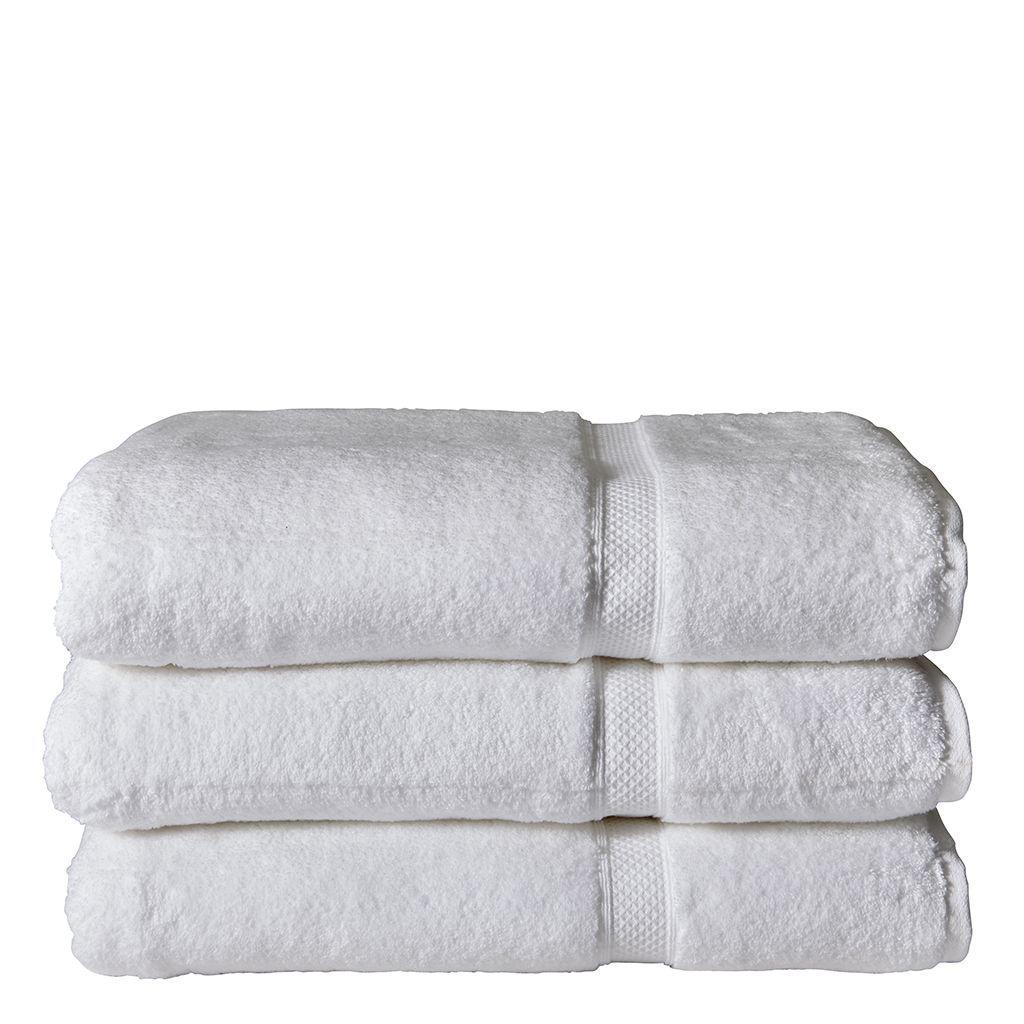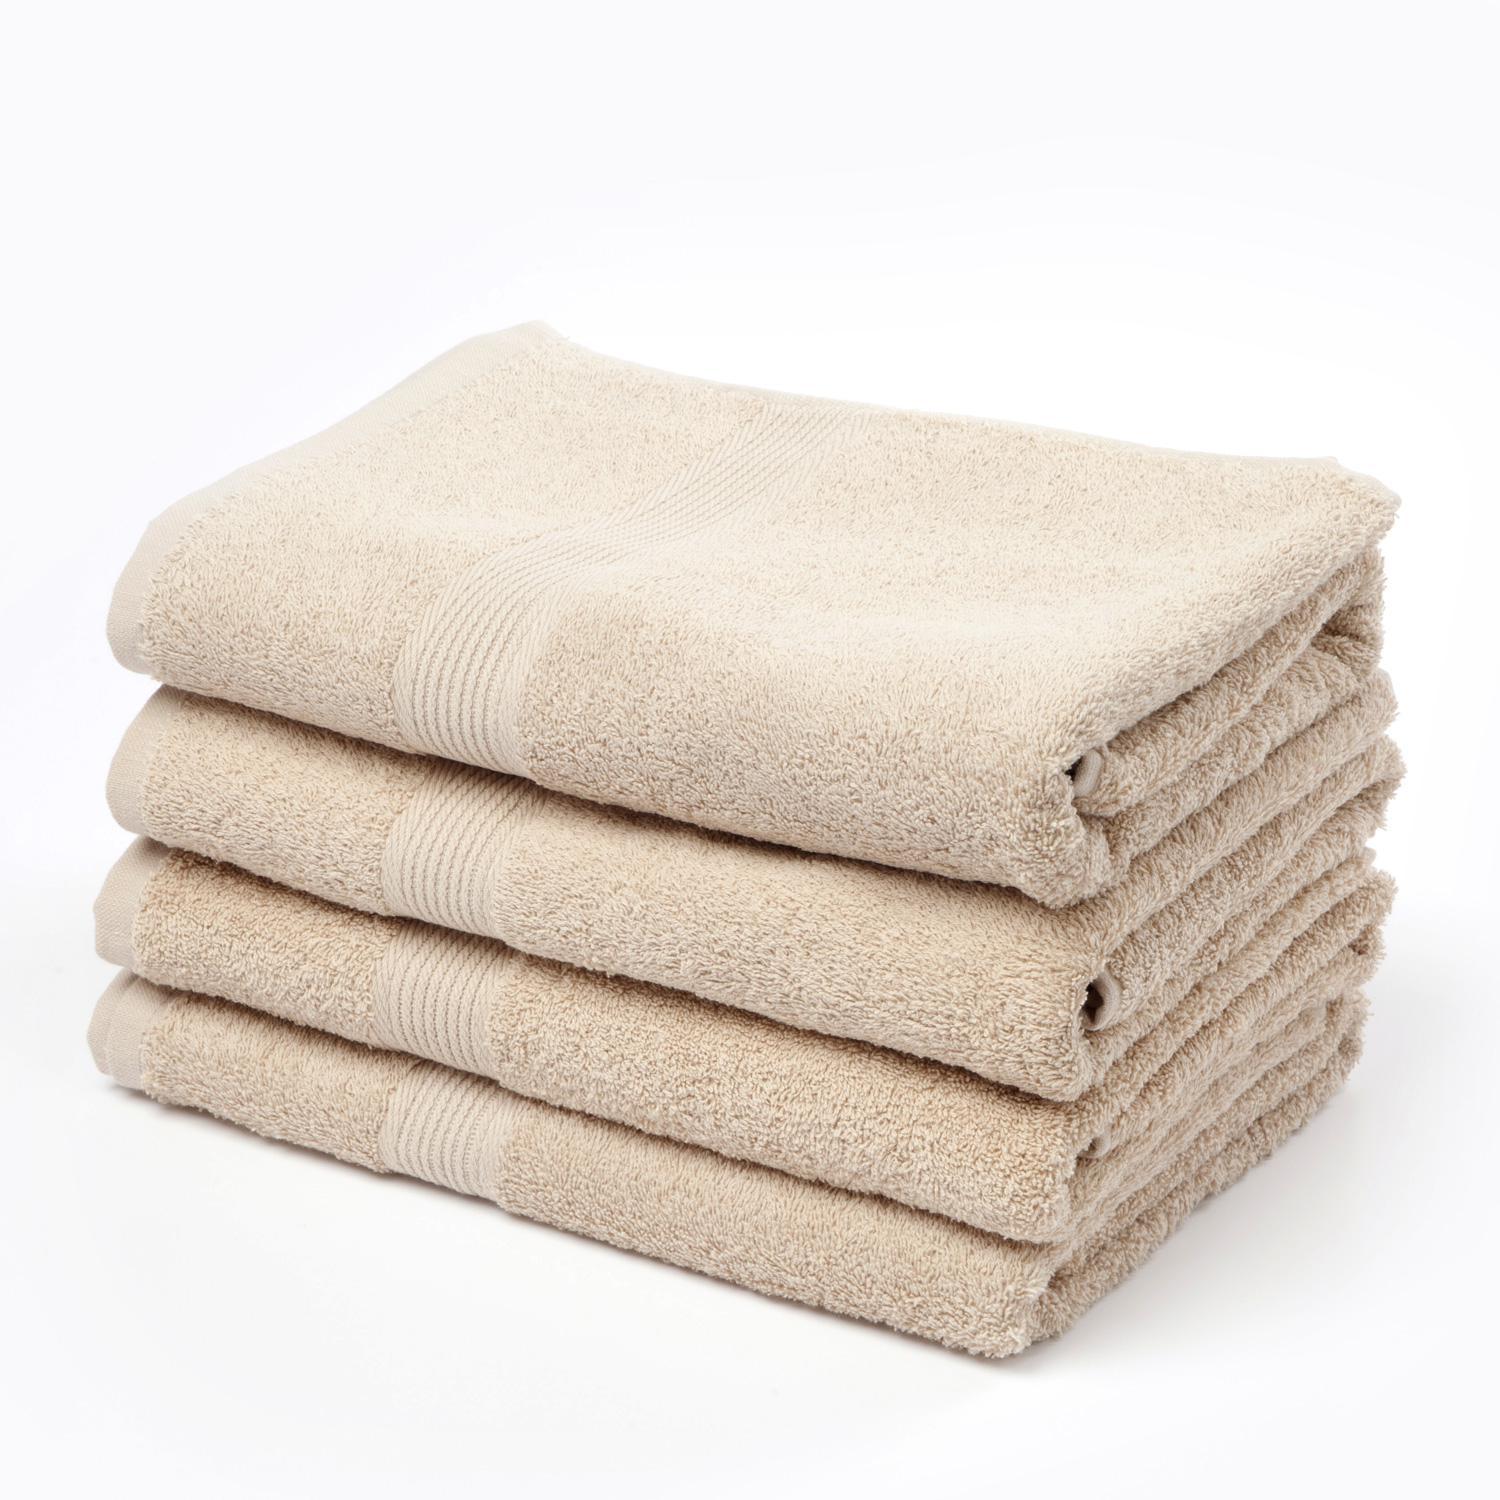The first image is the image on the left, the second image is the image on the right. Examine the images to the left and right. Is the description "One image features a stack of exactly three solid white folded towels." accurate? Answer yes or no. Yes. The first image is the image on the left, the second image is the image on the right. For the images displayed, is the sentence "Three white towels are stacked on each other in the image on the left." factually correct? Answer yes or no. Yes. 